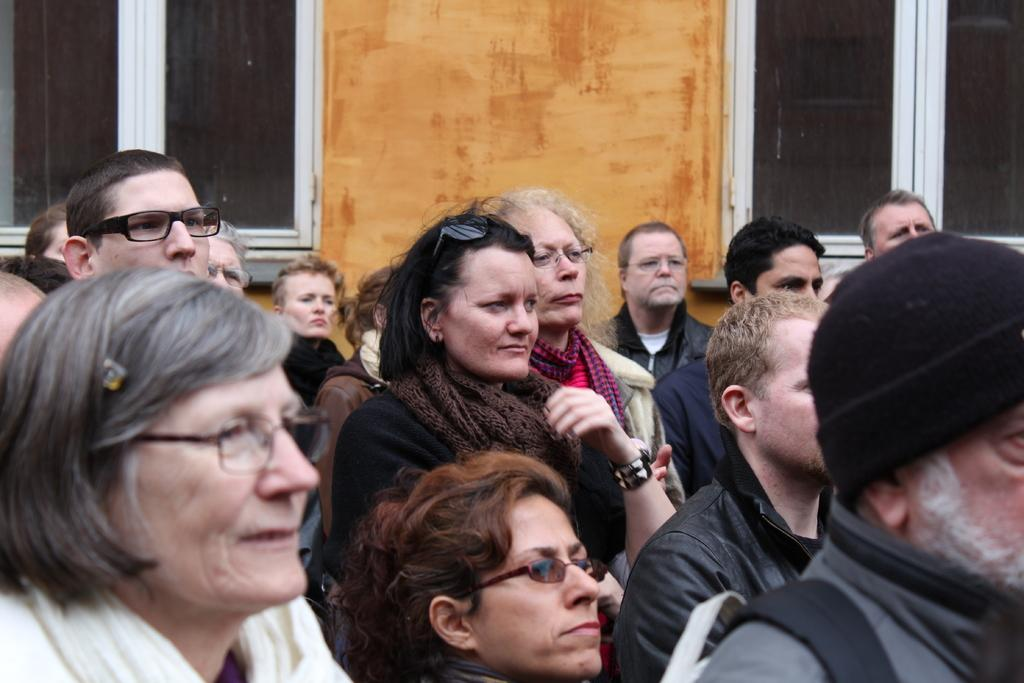What types of people are present in the image? There are women and men in the image. What are the women and men doing in the image? The women and men are standing and looking. What can be seen in the background of the image? There is an orange wall in the background of the image. What type of architectural feature is present in the image? There are glass windows in the image. How many books can be seen on the ship in the image? There is no ship or books present in the image. What type of loaf is being prepared by the women in the image? There is no loaf or baking activity depicted in the image; the women and men are standing and looking. 